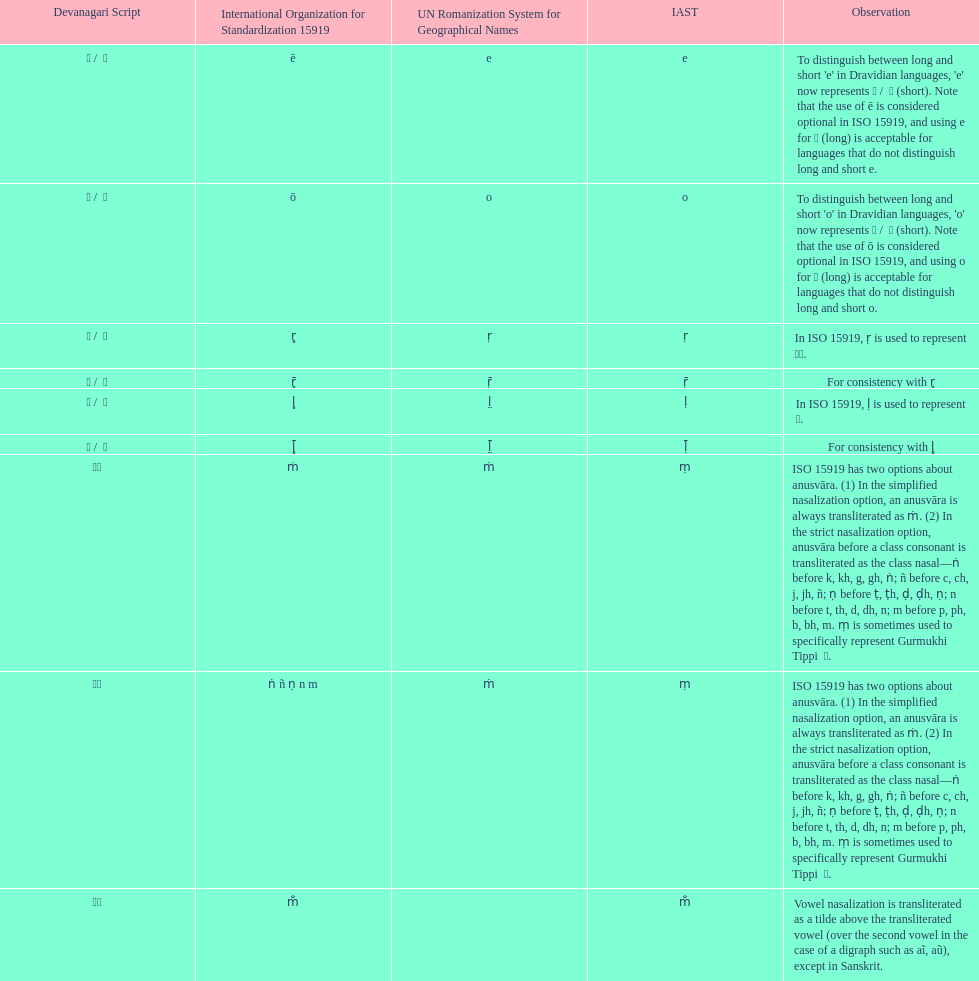This table shows the difference between how many transliterations? 3. 